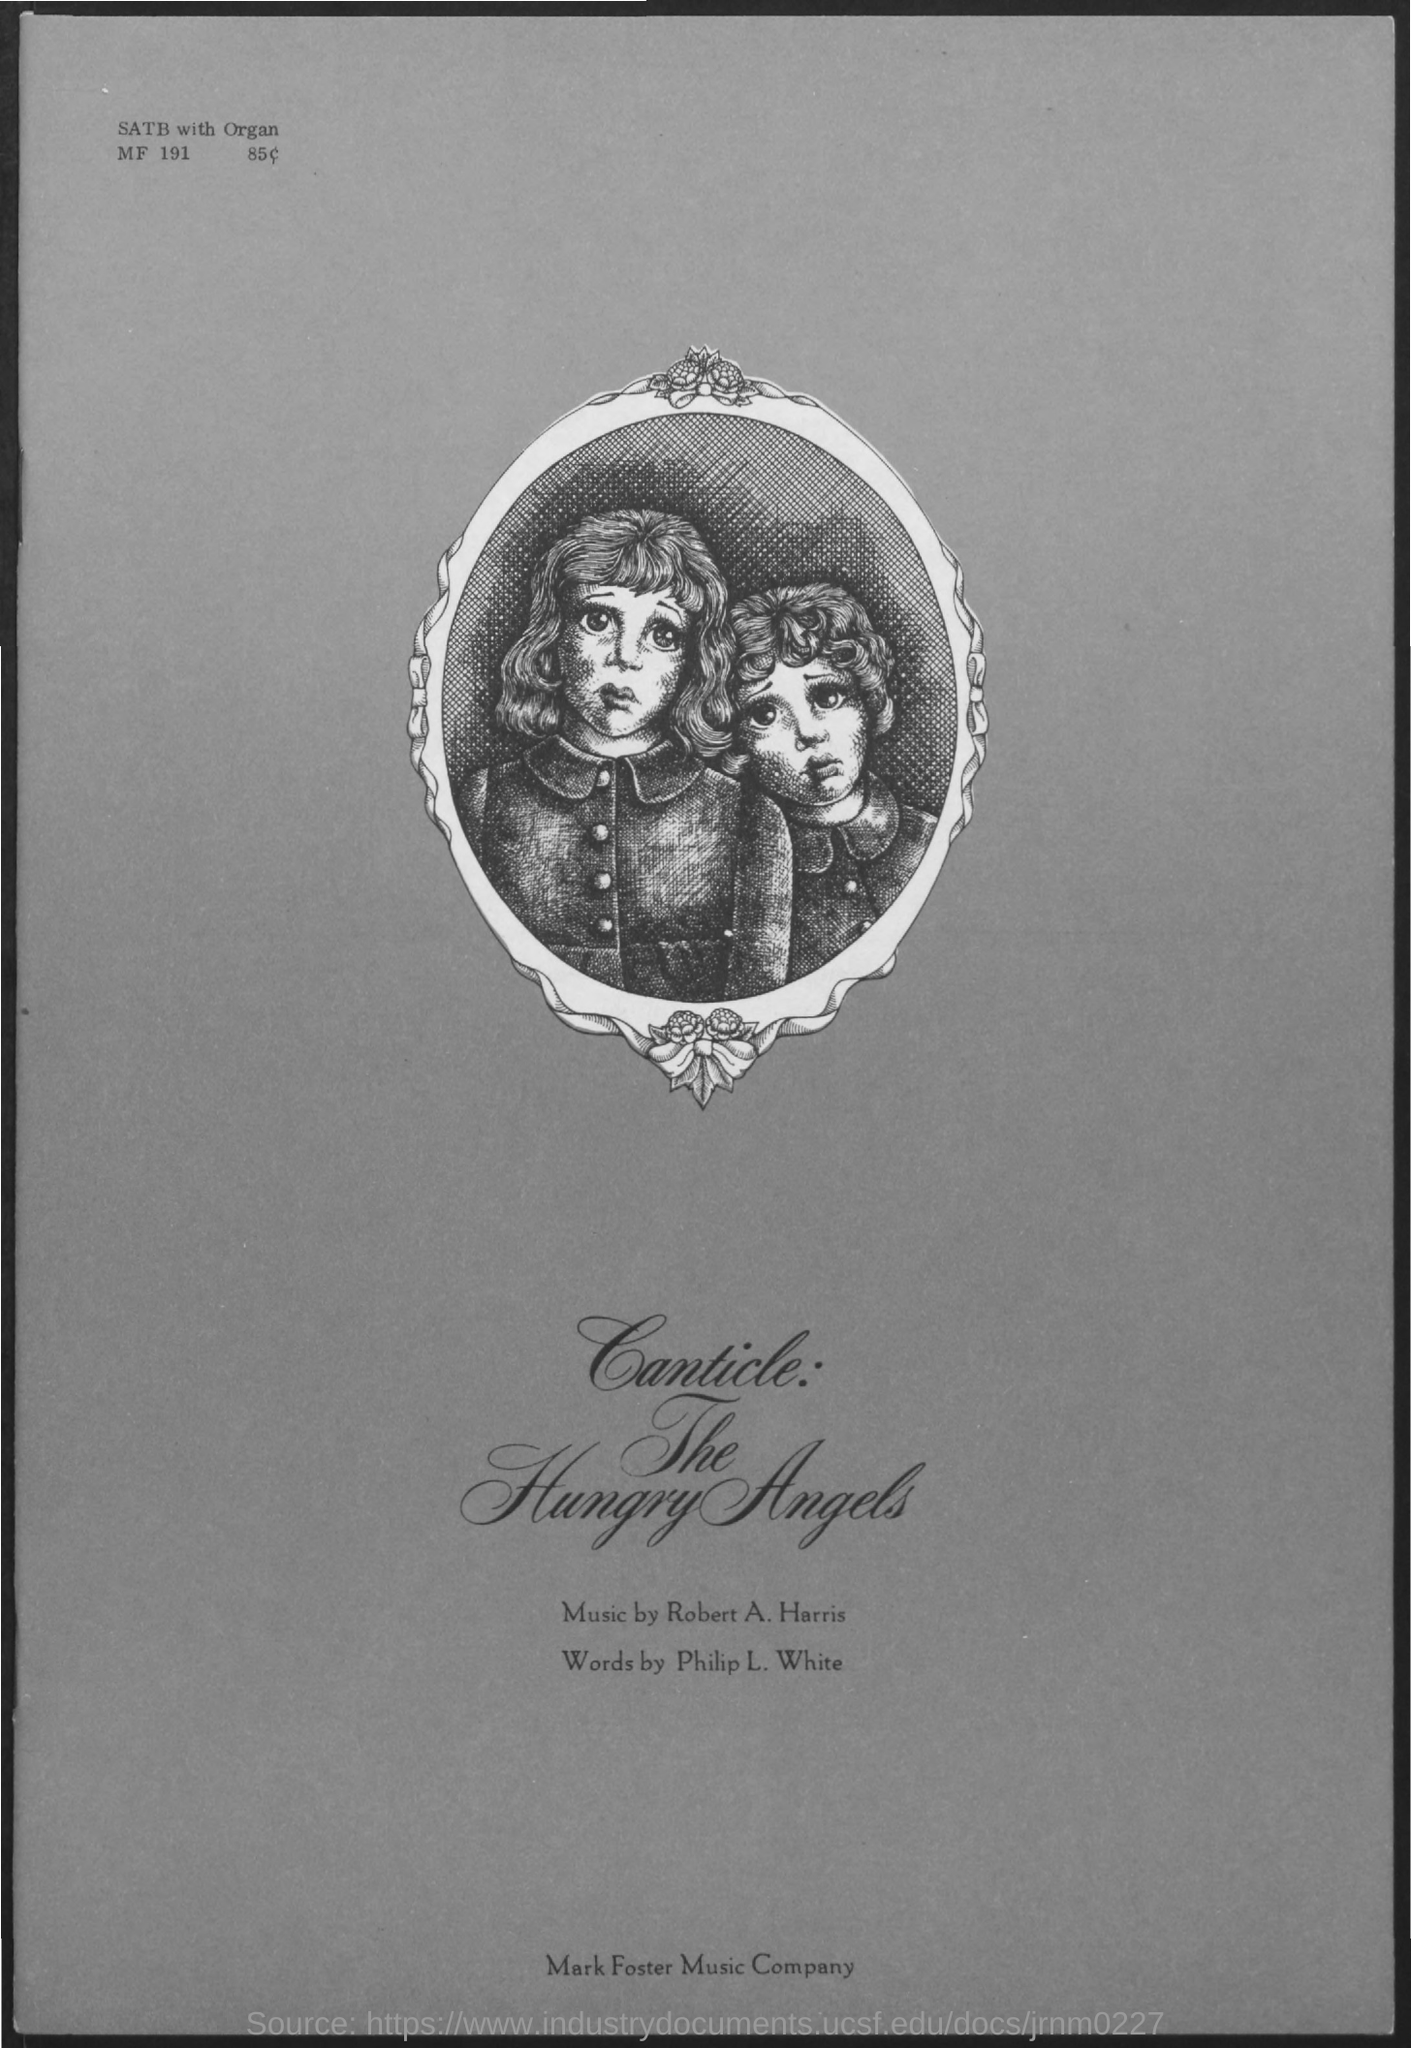By whom the music was composed ?
Offer a very short reply. ROBERT A. HARRIS. By whom the words was written ?
Your answer should be very brief. PHILIP L. WHITE. 